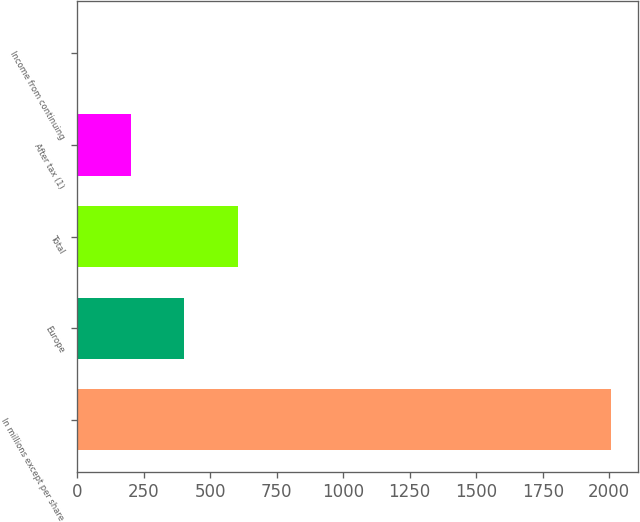<chart> <loc_0><loc_0><loc_500><loc_500><bar_chart><fcel>In millions except per share<fcel>Europe<fcel>Total<fcel>After tax (1)<fcel>Income from continuing<nl><fcel>2008<fcel>401.61<fcel>602.41<fcel>200.81<fcel>0.01<nl></chart> 